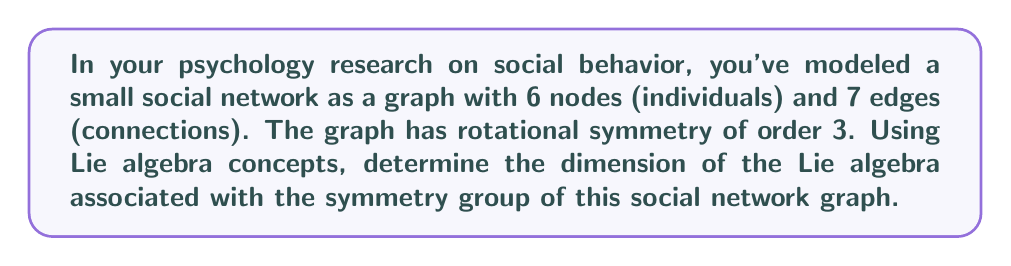Can you answer this question? To solve this problem, we'll follow these steps:

1) First, we need to identify the symmetry group of the graph. Given that it has rotational symmetry of order 3, the symmetry group is isomorphic to the cyclic group $C_3$.

2) The Lie group associated with $C_3$ is $SO(2)$, the special orthogonal group in 2 dimensions. This is because $C_3$ can be realized as a subgroup of rotations in the plane.

3) The Lie algebra associated with $SO(2)$ is $\mathfrak{so}(2)$, which consists of 2x2 skew-symmetric matrices.

4) A general element of $\mathfrak{so}(2)$ has the form:

   $$\begin{pmatrix}
   0 & -a \\
   a & 0
   \end{pmatrix}$$

   where $a$ is a real number.

5) The dimension of a Lie algebra is the number of independent parameters needed to specify an element of the algebra. In this case, we only need one parameter ($a$) to specify any element of $\mathfrak{so}(2)$.

Therefore, the dimension of the Lie algebra associated with the symmetry group of this social network graph is 1.

This result reflects the fact that the graph's symmetry is characterized by a single degree of freedom: the angle of rotation about the center.
Answer: The dimension of the Lie algebra associated with the symmetry group of the social network graph is 1. 